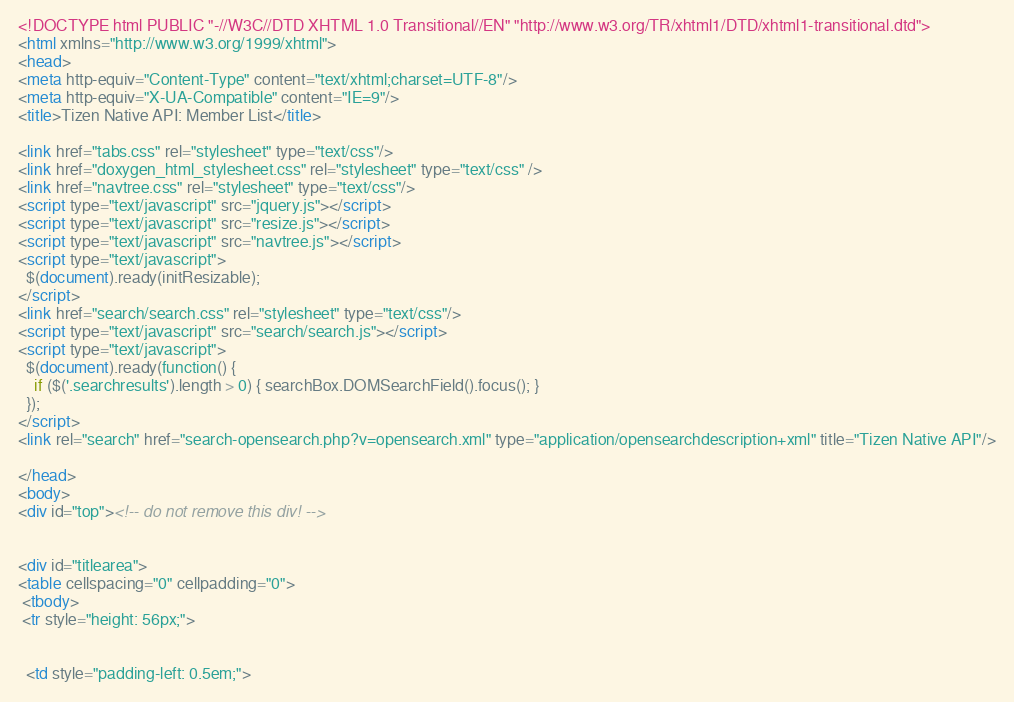<code> <loc_0><loc_0><loc_500><loc_500><_HTML_><!DOCTYPE html PUBLIC "-//W3C//DTD XHTML 1.0 Transitional//EN" "http://www.w3.org/TR/xhtml1/DTD/xhtml1-transitional.dtd">
<html xmlns="http://www.w3.org/1999/xhtml">
<head>
<meta http-equiv="Content-Type" content="text/xhtml;charset=UTF-8"/>
<meta http-equiv="X-UA-Compatible" content="IE=9"/>
<title>Tizen Native API: Member List</title>

<link href="tabs.css" rel="stylesheet" type="text/css"/>
<link href="doxygen_html_stylesheet.css" rel="stylesheet" type="text/css" />
<link href="navtree.css" rel="stylesheet" type="text/css"/>
<script type="text/javascript" src="jquery.js"></script>
<script type="text/javascript" src="resize.js"></script>
<script type="text/javascript" src="navtree.js"></script>
<script type="text/javascript">
  $(document).ready(initResizable);
</script>
<link href="search/search.css" rel="stylesheet" type="text/css"/>
<script type="text/javascript" src="search/search.js"></script>
<script type="text/javascript">
  $(document).ready(function() {
    if ($('.searchresults').length > 0) { searchBox.DOMSearchField().focus(); }
  });
</script>
<link rel="search" href="search-opensearch.php?v=opensearch.xml" type="application/opensearchdescription+xml" title="Tizen Native API"/>

</head>
<body>
<div id="top"><!-- do not remove this div! -->


<div id="titlearea">
<table cellspacing="0" cellpadding="0">
 <tbody>
 <tr style="height: 56px;">
  
  
  <td style="padding-left: 0.5em;"></code> 